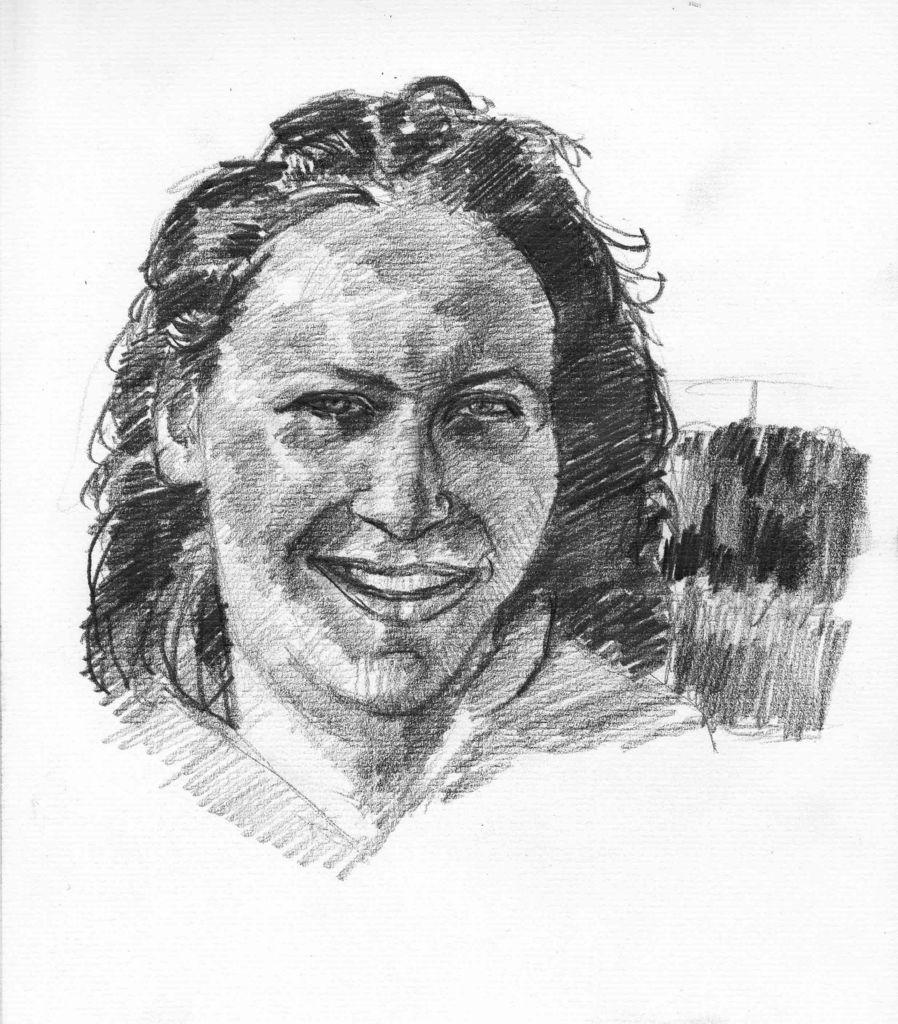What is the main subject of the image? There is a sketch of a person in the center of the image. How does the person in the sketch kick a ball in the image? There is no ball present in the image, and the person in the sketch is not shown kicking anything. 